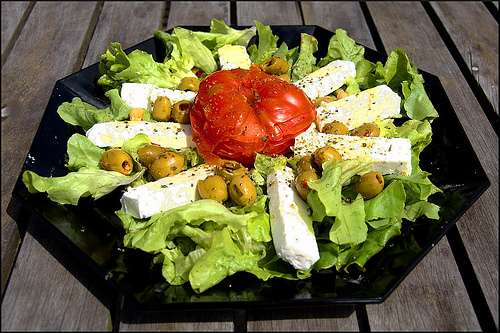<image>
Can you confirm if the cheese is under the olive? No. The cheese is not positioned under the olive. The vertical relationship between these objects is different. Where is the leaf in relation to the olive? Is it to the right of the olive? Yes. From this viewpoint, the leaf is positioned to the right side relative to the olive. 